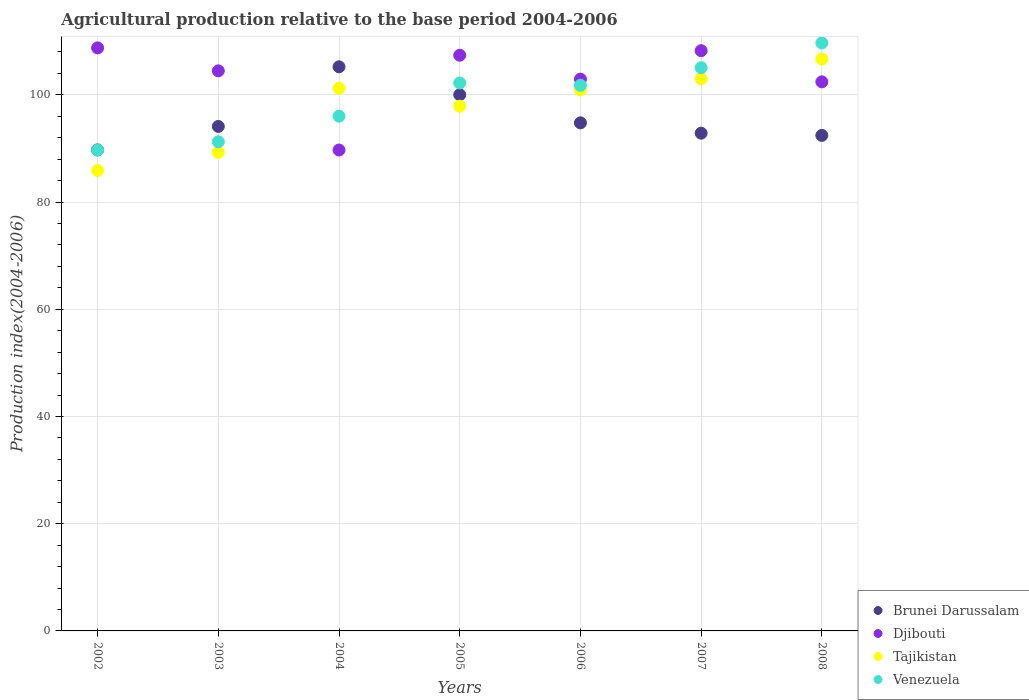What is the agricultural production index in Brunei Darussalam in 2008?
Ensure brevity in your answer.  92.43. Across all years, what is the maximum agricultural production index in Brunei Darussalam?
Your answer should be compact. 105.22. Across all years, what is the minimum agricultural production index in Venezuela?
Make the answer very short. 89.69. In which year was the agricultural production index in Tajikistan minimum?
Your answer should be very brief. 2002. What is the total agricultural production index in Brunei Darussalam in the graph?
Provide a short and direct response. 669.09. What is the difference between the agricultural production index in Venezuela in 2003 and that in 2006?
Give a very brief answer. -10.54. What is the difference between the agricultural production index in Djibouti in 2006 and the agricultural production index in Tajikistan in 2003?
Your response must be concise. 13.66. What is the average agricultural production index in Djibouti per year?
Your answer should be compact. 103.41. In the year 2002, what is the difference between the agricultural production index in Djibouti and agricultural production index in Brunei Darussalam?
Your answer should be very brief. 19.03. In how many years, is the agricultural production index in Tajikistan greater than 44?
Ensure brevity in your answer.  7. What is the ratio of the agricultural production index in Brunei Darussalam in 2003 to that in 2007?
Offer a very short reply. 1.01. Is the agricultural production index in Brunei Darussalam in 2003 less than that in 2005?
Give a very brief answer. Yes. What is the difference between the highest and the second highest agricultural production index in Djibouti?
Your response must be concise. 0.52. What is the difference between the highest and the lowest agricultural production index in Tajikistan?
Keep it short and to the point. 20.8. In how many years, is the agricultural production index in Djibouti greater than the average agricultural production index in Djibouti taken over all years?
Provide a short and direct response. 4. Is the agricultural production index in Djibouti strictly greater than the agricultural production index in Venezuela over the years?
Ensure brevity in your answer.  No. How many years are there in the graph?
Offer a very short reply. 7. Are the values on the major ticks of Y-axis written in scientific E-notation?
Keep it short and to the point. No. Does the graph contain any zero values?
Your answer should be compact. No. Does the graph contain grids?
Offer a terse response. Yes. Where does the legend appear in the graph?
Offer a very short reply. Bottom right. How many legend labels are there?
Give a very brief answer. 4. What is the title of the graph?
Keep it short and to the point. Agricultural production relative to the base period 2004-2006. What is the label or title of the Y-axis?
Make the answer very short. Production index(2004-2006). What is the Production index(2004-2006) in Brunei Darussalam in 2002?
Your answer should be compact. 89.72. What is the Production index(2004-2006) in Djibouti in 2002?
Give a very brief answer. 108.75. What is the Production index(2004-2006) in Tajikistan in 2002?
Give a very brief answer. 85.87. What is the Production index(2004-2006) in Venezuela in 2002?
Your response must be concise. 89.69. What is the Production index(2004-2006) in Brunei Darussalam in 2003?
Ensure brevity in your answer.  94.1. What is the Production index(2004-2006) of Djibouti in 2003?
Offer a very short reply. 104.47. What is the Production index(2004-2006) in Tajikistan in 2003?
Give a very brief answer. 89.26. What is the Production index(2004-2006) of Venezuela in 2003?
Your response must be concise. 91.24. What is the Production index(2004-2006) in Brunei Darussalam in 2004?
Provide a succinct answer. 105.22. What is the Production index(2004-2006) of Djibouti in 2004?
Provide a succinct answer. 89.7. What is the Production index(2004-2006) in Tajikistan in 2004?
Provide a succinct answer. 101.21. What is the Production index(2004-2006) in Venezuela in 2004?
Make the answer very short. 96.01. What is the Production index(2004-2006) of Brunei Darussalam in 2005?
Make the answer very short. 100.01. What is the Production index(2004-2006) in Djibouti in 2005?
Ensure brevity in your answer.  107.38. What is the Production index(2004-2006) of Tajikistan in 2005?
Give a very brief answer. 97.88. What is the Production index(2004-2006) of Venezuela in 2005?
Offer a terse response. 102.21. What is the Production index(2004-2006) in Brunei Darussalam in 2006?
Ensure brevity in your answer.  94.77. What is the Production index(2004-2006) in Djibouti in 2006?
Make the answer very short. 102.92. What is the Production index(2004-2006) in Tajikistan in 2006?
Keep it short and to the point. 100.91. What is the Production index(2004-2006) in Venezuela in 2006?
Ensure brevity in your answer.  101.78. What is the Production index(2004-2006) in Brunei Darussalam in 2007?
Make the answer very short. 92.84. What is the Production index(2004-2006) of Djibouti in 2007?
Give a very brief answer. 108.23. What is the Production index(2004-2006) in Tajikistan in 2007?
Your response must be concise. 102.99. What is the Production index(2004-2006) in Venezuela in 2007?
Make the answer very short. 105.06. What is the Production index(2004-2006) of Brunei Darussalam in 2008?
Provide a short and direct response. 92.43. What is the Production index(2004-2006) of Djibouti in 2008?
Offer a very short reply. 102.42. What is the Production index(2004-2006) of Tajikistan in 2008?
Your answer should be very brief. 106.67. What is the Production index(2004-2006) of Venezuela in 2008?
Your response must be concise. 109.67. Across all years, what is the maximum Production index(2004-2006) of Brunei Darussalam?
Your answer should be very brief. 105.22. Across all years, what is the maximum Production index(2004-2006) of Djibouti?
Offer a very short reply. 108.75. Across all years, what is the maximum Production index(2004-2006) in Tajikistan?
Your response must be concise. 106.67. Across all years, what is the maximum Production index(2004-2006) in Venezuela?
Offer a very short reply. 109.67. Across all years, what is the minimum Production index(2004-2006) of Brunei Darussalam?
Give a very brief answer. 89.72. Across all years, what is the minimum Production index(2004-2006) of Djibouti?
Offer a terse response. 89.7. Across all years, what is the minimum Production index(2004-2006) in Tajikistan?
Offer a terse response. 85.87. Across all years, what is the minimum Production index(2004-2006) of Venezuela?
Provide a succinct answer. 89.69. What is the total Production index(2004-2006) in Brunei Darussalam in the graph?
Your response must be concise. 669.09. What is the total Production index(2004-2006) of Djibouti in the graph?
Your answer should be very brief. 723.87. What is the total Production index(2004-2006) of Tajikistan in the graph?
Your answer should be very brief. 684.79. What is the total Production index(2004-2006) in Venezuela in the graph?
Offer a very short reply. 695.66. What is the difference between the Production index(2004-2006) of Brunei Darussalam in 2002 and that in 2003?
Keep it short and to the point. -4.38. What is the difference between the Production index(2004-2006) in Djibouti in 2002 and that in 2003?
Give a very brief answer. 4.28. What is the difference between the Production index(2004-2006) of Tajikistan in 2002 and that in 2003?
Your answer should be very brief. -3.39. What is the difference between the Production index(2004-2006) in Venezuela in 2002 and that in 2003?
Ensure brevity in your answer.  -1.55. What is the difference between the Production index(2004-2006) in Brunei Darussalam in 2002 and that in 2004?
Your answer should be very brief. -15.5. What is the difference between the Production index(2004-2006) in Djibouti in 2002 and that in 2004?
Offer a very short reply. 19.05. What is the difference between the Production index(2004-2006) in Tajikistan in 2002 and that in 2004?
Provide a succinct answer. -15.34. What is the difference between the Production index(2004-2006) in Venezuela in 2002 and that in 2004?
Provide a short and direct response. -6.32. What is the difference between the Production index(2004-2006) in Brunei Darussalam in 2002 and that in 2005?
Your answer should be compact. -10.29. What is the difference between the Production index(2004-2006) in Djibouti in 2002 and that in 2005?
Offer a terse response. 1.37. What is the difference between the Production index(2004-2006) in Tajikistan in 2002 and that in 2005?
Make the answer very short. -12.01. What is the difference between the Production index(2004-2006) in Venezuela in 2002 and that in 2005?
Offer a terse response. -12.52. What is the difference between the Production index(2004-2006) of Brunei Darussalam in 2002 and that in 2006?
Provide a succinct answer. -5.05. What is the difference between the Production index(2004-2006) of Djibouti in 2002 and that in 2006?
Make the answer very short. 5.83. What is the difference between the Production index(2004-2006) in Tajikistan in 2002 and that in 2006?
Your answer should be very brief. -15.04. What is the difference between the Production index(2004-2006) of Venezuela in 2002 and that in 2006?
Give a very brief answer. -12.09. What is the difference between the Production index(2004-2006) of Brunei Darussalam in 2002 and that in 2007?
Offer a very short reply. -3.12. What is the difference between the Production index(2004-2006) in Djibouti in 2002 and that in 2007?
Your answer should be compact. 0.52. What is the difference between the Production index(2004-2006) in Tajikistan in 2002 and that in 2007?
Your answer should be compact. -17.12. What is the difference between the Production index(2004-2006) of Venezuela in 2002 and that in 2007?
Your answer should be compact. -15.37. What is the difference between the Production index(2004-2006) of Brunei Darussalam in 2002 and that in 2008?
Provide a succinct answer. -2.71. What is the difference between the Production index(2004-2006) of Djibouti in 2002 and that in 2008?
Ensure brevity in your answer.  6.33. What is the difference between the Production index(2004-2006) in Tajikistan in 2002 and that in 2008?
Ensure brevity in your answer.  -20.8. What is the difference between the Production index(2004-2006) of Venezuela in 2002 and that in 2008?
Give a very brief answer. -19.98. What is the difference between the Production index(2004-2006) of Brunei Darussalam in 2003 and that in 2004?
Provide a short and direct response. -11.12. What is the difference between the Production index(2004-2006) of Djibouti in 2003 and that in 2004?
Ensure brevity in your answer.  14.77. What is the difference between the Production index(2004-2006) in Tajikistan in 2003 and that in 2004?
Give a very brief answer. -11.95. What is the difference between the Production index(2004-2006) of Venezuela in 2003 and that in 2004?
Ensure brevity in your answer.  -4.77. What is the difference between the Production index(2004-2006) of Brunei Darussalam in 2003 and that in 2005?
Your answer should be very brief. -5.91. What is the difference between the Production index(2004-2006) in Djibouti in 2003 and that in 2005?
Provide a succinct answer. -2.91. What is the difference between the Production index(2004-2006) of Tajikistan in 2003 and that in 2005?
Your answer should be compact. -8.62. What is the difference between the Production index(2004-2006) of Venezuela in 2003 and that in 2005?
Provide a succinct answer. -10.97. What is the difference between the Production index(2004-2006) in Brunei Darussalam in 2003 and that in 2006?
Give a very brief answer. -0.67. What is the difference between the Production index(2004-2006) in Djibouti in 2003 and that in 2006?
Your answer should be compact. 1.55. What is the difference between the Production index(2004-2006) of Tajikistan in 2003 and that in 2006?
Offer a terse response. -11.65. What is the difference between the Production index(2004-2006) in Venezuela in 2003 and that in 2006?
Offer a very short reply. -10.54. What is the difference between the Production index(2004-2006) in Brunei Darussalam in 2003 and that in 2007?
Your answer should be compact. 1.26. What is the difference between the Production index(2004-2006) in Djibouti in 2003 and that in 2007?
Your answer should be compact. -3.76. What is the difference between the Production index(2004-2006) in Tajikistan in 2003 and that in 2007?
Offer a very short reply. -13.73. What is the difference between the Production index(2004-2006) of Venezuela in 2003 and that in 2007?
Provide a short and direct response. -13.82. What is the difference between the Production index(2004-2006) of Brunei Darussalam in 2003 and that in 2008?
Make the answer very short. 1.67. What is the difference between the Production index(2004-2006) of Djibouti in 2003 and that in 2008?
Your response must be concise. 2.05. What is the difference between the Production index(2004-2006) in Tajikistan in 2003 and that in 2008?
Provide a succinct answer. -17.41. What is the difference between the Production index(2004-2006) in Venezuela in 2003 and that in 2008?
Keep it short and to the point. -18.43. What is the difference between the Production index(2004-2006) of Brunei Darussalam in 2004 and that in 2005?
Give a very brief answer. 5.21. What is the difference between the Production index(2004-2006) in Djibouti in 2004 and that in 2005?
Offer a very short reply. -17.68. What is the difference between the Production index(2004-2006) in Tajikistan in 2004 and that in 2005?
Make the answer very short. 3.33. What is the difference between the Production index(2004-2006) in Venezuela in 2004 and that in 2005?
Provide a short and direct response. -6.2. What is the difference between the Production index(2004-2006) in Brunei Darussalam in 2004 and that in 2006?
Provide a succinct answer. 10.45. What is the difference between the Production index(2004-2006) of Djibouti in 2004 and that in 2006?
Your answer should be compact. -13.22. What is the difference between the Production index(2004-2006) in Venezuela in 2004 and that in 2006?
Your answer should be very brief. -5.77. What is the difference between the Production index(2004-2006) of Brunei Darussalam in 2004 and that in 2007?
Ensure brevity in your answer.  12.38. What is the difference between the Production index(2004-2006) of Djibouti in 2004 and that in 2007?
Keep it short and to the point. -18.53. What is the difference between the Production index(2004-2006) of Tajikistan in 2004 and that in 2007?
Give a very brief answer. -1.78. What is the difference between the Production index(2004-2006) in Venezuela in 2004 and that in 2007?
Your answer should be compact. -9.05. What is the difference between the Production index(2004-2006) of Brunei Darussalam in 2004 and that in 2008?
Offer a terse response. 12.79. What is the difference between the Production index(2004-2006) in Djibouti in 2004 and that in 2008?
Provide a succinct answer. -12.72. What is the difference between the Production index(2004-2006) in Tajikistan in 2004 and that in 2008?
Offer a terse response. -5.46. What is the difference between the Production index(2004-2006) of Venezuela in 2004 and that in 2008?
Offer a very short reply. -13.66. What is the difference between the Production index(2004-2006) of Brunei Darussalam in 2005 and that in 2006?
Offer a very short reply. 5.24. What is the difference between the Production index(2004-2006) of Djibouti in 2005 and that in 2006?
Keep it short and to the point. 4.46. What is the difference between the Production index(2004-2006) in Tajikistan in 2005 and that in 2006?
Your response must be concise. -3.03. What is the difference between the Production index(2004-2006) of Venezuela in 2005 and that in 2006?
Your response must be concise. 0.43. What is the difference between the Production index(2004-2006) of Brunei Darussalam in 2005 and that in 2007?
Provide a short and direct response. 7.17. What is the difference between the Production index(2004-2006) in Djibouti in 2005 and that in 2007?
Give a very brief answer. -0.85. What is the difference between the Production index(2004-2006) in Tajikistan in 2005 and that in 2007?
Keep it short and to the point. -5.11. What is the difference between the Production index(2004-2006) of Venezuela in 2005 and that in 2007?
Keep it short and to the point. -2.85. What is the difference between the Production index(2004-2006) of Brunei Darussalam in 2005 and that in 2008?
Provide a short and direct response. 7.58. What is the difference between the Production index(2004-2006) of Djibouti in 2005 and that in 2008?
Keep it short and to the point. 4.96. What is the difference between the Production index(2004-2006) of Tajikistan in 2005 and that in 2008?
Make the answer very short. -8.79. What is the difference between the Production index(2004-2006) of Venezuela in 2005 and that in 2008?
Offer a terse response. -7.46. What is the difference between the Production index(2004-2006) in Brunei Darussalam in 2006 and that in 2007?
Provide a succinct answer. 1.93. What is the difference between the Production index(2004-2006) of Djibouti in 2006 and that in 2007?
Your answer should be very brief. -5.31. What is the difference between the Production index(2004-2006) of Tajikistan in 2006 and that in 2007?
Make the answer very short. -2.08. What is the difference between the Production index(2004-2006) in Venezuela in 2006 and that in 2007?
Provide a succinct answer. -3.28. What is the difference between the Production index(2004-2006) in Brunei Darussalam in 2006 and that in 2008?
Your response must be concise. 2.34. What is the difference between the Production index(2004-2006) of Djibouti in 2006 and that in 2008?
Your answer should be very brief. 0.5. What is the difference between the Production index(2004-2006) in Tajikistan in 2006 and that in 2008?
Give a very brief answer. -5.76. What is the difference between the Production index(2004-2006) of Venezuela in 2006 and that in 2008?
Provide a short and direct response. -7.89. What is the difference between the Production index(2004-2006) of Brunei Darussalam in 2007 and that in 2008?
Provide a short and direct response. 0.41. What is the difference between the Production index(2004-2006) of Djibouti in 2007 and that in 2008?
Your response must be concise. 5.81. What is the difference between the Production index(2004-2006) of Tajikistan in 2007 and that in 2008?
Your answer should be compact. -3.68. What is the difference between the Production index(2004-2006) of Venezuela in 2007 and that in 2008?
Give a very brief answer. -4.61. What is the difference between the Production index(2004-2006) in Brunei Darussalam in 2002 and the Production index(2004-2006) in Djibouti in 2003?
Keep it short and to the point. -14.75. What is the difference between the Production index(2004-2006) of Brunei Darussalam in 2002 and the Production index(2004-2006) of Tajikistan in 2003?
Your answer should be compact. 0.46. What is the difference between the Production index(2004-2006) in Brunei Darussalam in 2002 and the Production index(2004-2006) in Venezuela in 2003?
Keep it short and to the point. -1.52. What is the difference between the Production index(2004-2006) in Djibouti in 2002 and the Production index(2004-2006) in Tajikistan in 2003?
Provide a succinct answer. 19.49. What is the difference between the Production index(2004-2006) in Djibouti in 2002 and the Production index(2004-2006) in Venezuela in 2003?
Ensure brevity in your answer.  17.51. What is the difference between the Production index(2004-2006) in Tajikistan in 2002 and the Production index(2004-2006) in Venezuela in 2003?
Offer a terse response. -5.37. What is the difference between the Production index(2004-2006) of Brunei Darussalam in 2002 and the Production index(2004-2006) of Tajikistan in 2004?
Your answer should be compact. -11.49. What is the difference between the Production index(2004-2006) in Brunei Darussalam in 2002 and the Production index(2004-2006) in Venezuela in 2004?
Give a very brief answer. -6.29. What is the difference between the Production index(2004-2006) of Djibouti in 2002 and the Production index(2004-2006) of Tajikistan in 2004?
Offer a terse response. 7.54. What is the difference between the Production index(2004-2006) in Djibouti in 2002 and the Production index(2004-2006) in Venezuela in 2004?
Your response must be concise. 12.74. What is the difference between the Production index(2004-2006) in Tajikistan in 2002 and the Production index(2004-2006) in Venezuela in 2004?
Offer a very short reply. -10.14. What is the difference between the Production index(2004-2006) of Brunei Darussalam in 2002 and the Production index(2004-2006) of Djibouti in 2005?
Make the answer very short. -17.66. What is the difference between the Production index(2004-2006) in Brunei Darussalam in 2002 and the Production index(2004-2006) in Tajikistan in 2005?
Offer a terse response. -8.16. What is the difference between the Production index(2004-2006) in Brunei Darussalam in 2002 and the Production index(2004-2006) in Venezuela in 2005?
Make the answer very short. -12.49. What is the difference between the Production index(2004-2006) in Djibouti in 2002 and the Production index(2004-2006) in Tajikistan in 2005?
Ensure brevity in your answer.  10.87. What is the difference between the Production index(2004-2006) in Djibouti in 2002 and the Production index(2004-2006) in Venezuela in 2005?
Provide a short and direct response. 6.54. What is the difference between the Production index(2004-2006) in Tajikistan in 2002 and the Production index(2004-2006) in Venezuela in 2005?
Give a very brief answer. -16.34. What is the difference between the Production index(2004-2006) of Brunei Darussalam in 2002 and the Production index(2004-2006) of Djibouti in 2006?
Ensure brevity in your answer.  -13.2. What is the difference between the Production index(2004-2006) in Brunei Darussalam in 2002 and the Production index(2004-2006) in Tajikistan in 2006?
Provide a succinct answer. -11.19. What is the difference between the Production index(2004-2006) in Brunei Darussalam in 2002 and the Production index(2004-2006) in Venezuela in 2006?
Your response must be concise. -12.06. What is the difference between the Production index(2004-2006) in Djibouti in 2002 and the Production index(2004-2006) in Tajikistan in 2006?
Provide a succinct answer. 7.84. What is the difference between the Production index(2004-2006) in Djibouti in 2002 and the Production index(2004-2006) in Venezuela in 2006?
Your response must be concise. 6.97. What is the difference between the Production index(2004-2006) of Tajikistan in 2002 and the Production index(2004-2006) of Venezuela in 2006?
Provide a succinct answer. -15.91. What is the difference between the Production index(2004-2006) of Brunei Darussalam in 2002 and the Production index(2004-2006) of Djibouti in 2007?
Keep it short and to the point. -18.51. What is the difference between the Production index(2004-2006) in Brunei Darussalam in 2002 and the Production index(2004-2006) in Tajikistan in 2007?
Provide a succinct answer. -13.27. What is the difference between the Production index(2004-2006) of Brunei Darussalam in 2002 and the Production index(2004-2006) of Venezuela in 2007?
Offer a very short reply. -15.34. What is the difference between the Production index(2004-2006) of Djibouti in 2002 and the Production index(2004-2006) of Tajikistan in 2007?
Ensure brevity in your answer.  5.76. What is the difference between the Production index(2004-2006) of Djibouti in 2002 and the Production index(2004-2006) of Venezuela in 2007?
Keep it short and to the point. 3.69. What is the difference between the Production index(2004-2006) of Tajikistan in 2002 and the Production index(2004-2006) of Venezuela in 2007?
Your response must be concise. -19.19. What is the difference between the Production index(2004-2006) of Brunei Darussalam in 2002 and the Production index(2004-2006) of Djibouti in 2008?
Offer a terse response. -12.7. What is the difference between the Production index(2004-2006) in Brunei Darussalam in 2002 and the Production index(2004-2006) in Tajikistan in 2008?
Give a very brief answer. -16.95. What is the difference between the Production index(2004-2006) in Brunei Darussalam in 2002 and the Production index(2004-2006) in Venezuela in 2008?
Offer a very short reply. -19.95. What is the difference between the Production index(2004-2006) of Djibouti in 2002 and the Production index(2004-2006) of Tajikistan in 2008?
Your answer should be compact. 2.08. What is the difference between the Production index(2004-2006) of Djibouti in 2002 and the Production index(2004-2006) of Venezuela in 2008?
Offer a terse response. -0.92. What is the difference between the Production index(2004-2006) of Tajikistan in 2002 and the Production index(2004-2006) of Venezuela in 2008?
Give a very brief answer. -23.8. What is the difference between the Production index(2004-2006) of Brunei Darussalam in 2003 and the Production index(2004-2006) of Djibouti in 2004?
Keep it short and to the point. 4.4. What is the difference between the Production index(2004-2006) in Brunei Darussalam in 2003 and the Production index(2004-2006) in Tajikistan in 2004?
Your answer should be compact. -7.11. What is the difference between the Production index(2004-2006) of Brunei Darussalam in 2003 and the Production index(2004-2006) of Venezuela in 2004?
Your answer should be very brief. -1.91. What is the difference between the Production index(2004-2006) in Djibouti in 2003 and the Production index(2004-2006) in Tajikistan in 2004?
Give a very brief answer. 3.26. What is the difference between the Production index(2004-2006) in Djibouti in 2003 and the Production index(2004-2006) in Venezuela in 2004?
Ensure brevity in your answer.  8.46. What is the difference between the Production index(2004-2006) in Tajikistan in 2003 and the Production index(2004-2006) in Venezuela in 2004?
Ensure brevity in your answer.  -6.75. What is the difference between the Production index(2004-2006) in Brunei Darussalam in 2003 and the Production index(2004-2006) in Djibouti in 2005?
Make the answer very short. -13.28. What is the difference between the Production index(2004-2006) in Brunei Darussalam in 2003 and the Production index(2004-2006) in Tajikistan in 2005?
Provide a short and direct response. -3.78. What is the difference between the Production index(2004-2006) of Brunei Darussalam in 2003 and the Production index(2004-2006) of Venezuela in 2005?
Ensure brevity in your answer.  -8.11. What is the difference between the Production index(2004-2006) of Djibouti in 2003 and the Production index(2004-2006) of Tajikistan in 2005?
Give a very brief answer. 6.59. What is the difference between the Production index(2004-2006) in Djibouti in 2003 and the Production index(2004-2006) in Venezuela in 2005?
Give a very brief answer. 2.26. What is the difference between the Production index(2004-2006) of Tajikistan in 2003 and the Production index(2004-2006) of Venezuela in 2005?
Your response must be concise. -12.95. What is the difference between the Production index(2004-2006) in Brunei Darussalam in 2003 and the Production index(2004-2006) in Djibouti in 2006?
Offer a terse response. -8.82. What is the difference between the Production index(2004-2006) in Brunei Darussalam in 2003 and the Production index(2004-2006) in Tajikistan in 2006?
Ensure brevity in your answer.  -6.81. What is the difference between the Production index(2004-2006) of Brunei Darussalam in 2003 and the Production index(2004-2006) of Venezuela in 2006?
Your response must be concise. -7.68. What is the difference between the Production index(2004-2006) in Djibouti in 2003 and the Production index(2004-2006) in Tajikistan in 2006?
Keep it short and to the point. 3.56. What is the difference between the Production index(2004-2006) of Djibouti in 2003 and the Production index(2004-2006) of Venezuela in 2006?
Offer a terse response. 2.69. What is the difference between the Production index(2004-2006) of Tajikistan in 2003 and the Production index(2004-2006) of Venezuela in 2006?
Your response must be concise. -12.52. What is the difference between the Production index(2004-2006) of Brunei Darussalam in 2003 and the Production index(2004-2006) of Djibouti in 2007?
Ensure brevity in your answer.  -14.13. What is the difference between the Production index(2004-2006) in Brunei Darussalam in 2003 and the Production index(2004-2006) in Tajikistan in 2007?
Give a very brief answer. -8.89. What is the difference between the Production index(2004-2006) of Brunei Darussalam in 2003 and the Production index(2004-2006) of Venezuela in 2007?
Offer a terse response. -10.96. What is the difference between the Production index(2004-2006) in Djibouti in 2003 and the Production index(2004-2006) in Tajikistan in 2007?
Ensure brevity in your answer.  1.48. What is the difference between the Production index(2004-2006) in Djibouti in 2003 and the Production index(2004-2006) in Venezuela in 2007?
Your answer should be compact. -0.59. What is the difference between the Production index(2004-2006) in Tajikistan in 2003 and the Production index(2004-2006) in Venezuela in 2007?
Your answer should be compact. -15.8. What is the difference between the Production index(2004-2006) in Brunei Darussalam in 2003 and the Production index(2004-2006) in Djibouti in 2008?
Offer a terse response. -8.32. What is the difference between the Production index(2004-2006) of Brunei Darussalam in 2003 and the Production index(2004-2006) of Tajikistan in 2008?
Your answer should be very brief. -12.57. What is the difference between the Production index(2004-2006) of Brunei Darussalam in 2003 and the Production index(2004-2006) of Venezuela in 2008?
Provide a short and direct response. -15.57. What is the difference between the Production index(2004-2006) in Djibouti in 2003 and the Production index(2004-2006) in Tajikistan in 2008?
Ensure brevity in your answer.  -2.2. What is the difference between the Production index(2004-2006) in Tajikistan in 2003 and the Production index(2004-2006) in Venezuela in 2008?
Give a very brief answer. -20.41. What is the difference between the Production index(2004-2006) of Brunei Darussalam in 2004 and the Production index(2004-2006) of Djibouti in 2005?
Provide a short and direct response. -2.16. What is the difference between the Production index(2004-2006) in Brunei Darussalam in 2004 and the Production index(2004-2006) in Tajikistan in 2005?
Offer a terse response. 7.34. What is the difference between the Production index(2004-2006) in Brunei Darussalam in 2004 and the Production index(2004-2006) in Venezuela in 2005?
Your answer should be compact. 3.01. What is the difference between the Production index(2004-2006) of Djibouti in 2004 and the Production index(2004-2006) of Tajikistan in 2005?
Your answer should be compact. -8.18. What is the difference between the Production index(2004-2006) of Djibouti in 2004 and the Production index(2004-2006) of Venezuela in 2005?
Your answer should be compact. -12.51. What is the difference between the Production index(2004-2006) in Brunei Darussalam in 2004 and the Production index(2004-2006) in Djibouti in 2006?
Your response must be concise. 2.3. What is the difference between the Production index(2004-2006) in Brunei Darussalam in 2004 and the Production index(2004-2006) in Tajikistan in 2006?
Keep it short and to the point. 4.31. What is the difference between the Production index(2004-2006) in Brunei Darussalam in 2004 and the Production index(2004-2006) in Venezuela in 2006?
Give a very brief answer. 3.44. What is the difference between the Production index(2004-2006) of Djibouti in 2004 and the Production index(2004-2006) of Tajikistan in 2006?
Offer a very short reply. -11.21. What is the difference between the Production index(2004-2006) of Djibouti in 2004 and the Production index(2004-2006) of Venezuela in 2006?
Ensure brevity in your answer.  -12.08. What is the difference between the Production index(2004-2006) in Tajikistan in 2004 and the Production index(2004-2006) in Venezuela in 2006?
Make the answer very short. -0.57. What is the difference between the Production index(2004-2006) of Brunei Darussalam in 2004 and the Production index(2004-2006) of Djibouti in 2007?
Your answer should be very brief. -3.01. What is the difference between the Production index(2004-2006) in Brunei Darussalam in 2004 and the Production index(2004-2006) in Tajikistan in 2007?
Offer a very short reply. 2.23. What is the difference between the Production index(2004-2006) of Brunei Darussalam in 2004 and the Production index(2004-2006) of Venezuela in 2007?
Your answer should be compact. 0.16. What is the difference between the Production index(2004-2006) of Djibouti in 2004 and the Production index(2004-2006) of Tajikistan in 2007?
Give a very brief answer. -13.29. What is the difference between the Production index(2004-2006) in Djibouti in 2004 and the Production index(2004-2006) in Venezuela in 2007?
Your answer should be very brief. -15.36. What is the difference between the Production index(2004-2006) of Tajikistan in 2004 and the Production index(2004-2006) of Venezuela in 2007?
Provide a short and direct response. -3.85. What is the difference between the Production index(2004-2006) of Brunei Darussalam in 2004 and the Production index(2004-2006) of Djibouti in 2008?
Make the answer very short. 2.8. What is the difference between the Production index(2004-2006) in Brunei Darussalam in 2004 and the Production index(2004-2006) in Tajikistan in 2008?
Make the answer very short. -1.45. What is the difference between the Production index(2004-2006) in Brunei Darussalam in 2004 and the Production index(2004-2006) in Venezuela in 2008?
Keep it short and to the point. -4.45. What is the difference between the Production index(2004-2006) of Djibouti in 2004 and the Production index(2004-2006) of Tajikistan in 2008?
Your answer should be compact. -16.97. What is the difference between the Production index(2004-2006) of Djibouti in 2004 and the Production index(2004-2006) of Venezuela in 2008?
Provide a succinct answer. -19.97. What is the difference between the Production index(2004-2006) in Tajikistan in 2004 and the Production index(2004-2006) in Venezuela in 2008?
Offer a very short reply. -8.46. What is the difference between the Production index(2004-2006) of Brunei Darussalam in 2005 and the Production index(2004-2006) of Djibouti in 2006?
Your answer should be compact. -2.91. What is the difference between the Production index(2004-2006) of Brunei Darussalam in 2005 and the Production index(2004-2006) of Tajikistan in 2006?
Ensure brevity in your answer.  -0.9. What is the difference between the Production index(2004-2006) of Brunei Darussalam in 2005 and the Production index(2004-2006) of Venezuela in 2006?
Your answer should be compact. -1.77. What is the difference between the Production index(2004-2006) in Djibouti in 2005 and the Production index(2004-2006) in Tajikistan in 2006?
Offer a terse response. 6.47. What is the difference between the Production index(2004-2006) of Tajikistan in 2005 and the Production index(2004-2006) of Venezuela in 2006?
Your answer should be very brief. -3.9. What is the difference between the Production index(2004-2006) in Brunei Darussalam in 2005 and the Production index(2004-2006) in Djibouti in 2007?
Your answer should be very brief. -8.22. What is the difference between the Production index(2004-2006) in Brunei Darussalam in 2005 and the Production index(2004-2006) in Tajikistan in 2007?
Make the answer very short. -2.98. What is the difference between the Production index(2004-2006) of Brunei Darussalam in 2005 and the Production index(2004-2006) of Venezuela in 2007?
Your response must be concise. -5.05. What is the difference between the Production index(2004-2006) in Djibouti in 2005 and the Production index(2004-2006) in Tajikistan in 2007?
Give a very brief answer. 4.39. What is the difference between the Production index(2004-2006) of Djibouti in 2005 and the Production index(2004-2006) of Venezuela in 2007?
Provide a short and direct response. 2.32. What is the difference between the Production index(2004-2006) of Tajikistan in 2005 and the Production index(2004-2006) of Venezuela in 2007?
Offer a very short reply. -7.18. What is the difference between the Production index(2004-2006) of Brunei Darussalam in 2005 and the Production index(2004-2006) of Djibouti in 2008?
Offer a very short reply. -2.41. What is the difference between the Production index(2004-2006) in Brunei Darussalam in 2005 and the Production index(2004-2006) in Tajikistan in 2008?
Provide a succinct answer. -6.66. What is the difference between the Production index(2004-2006) of Brunei Darussalam in 2005 and the Production index(2004-2006) of Venezuela in 2008?
Your answer should be very brief. -9.66. What is the difference between the Production index(2004-2006) in Djibouti in 2005 and the Production index(2004-2006) in Tajikistan in 2008?
Give a very brief answer. 0.71. What is the difference between the Production index(2004-2006) in Djibouti in 2005 and the Production index(2004-2006) in Venezuela in 2008?
Provide a succinct answer. -2.29. What is the difference between the Production index(2004-2006) in Tajikistan in 2005 and the Production index(2004-2006) in Venezuela in 2008?
Offer a very short reply. -11.79. What is the difference between the Production index(2004-2006) in Brunei Darussalam in 2006 and the Production index(2004-2006) in Djibouti in 2007?
Make the answer very short. -13.46. What is the difference between the Production index(2004-2006) in Brunei Darussalam in 2006 and the Production index(2004-2006) in Tajikistan in 2007?
Make the answer very short. -8.22. What is the difference between the Production index(2004-2006) of Brunei Darussalam in 2006 and the Production index(2004-2006) of Venezuela in 2007?
Offer a very short reply. -10.29. What is the difference between the Production index(2004-2006) of Djibouti in 2006 and the Production index(2004-2006) of Tajikistan in 2007?
Provide a succinct answer. -0.07. What is the difference between the Production index(2004-2006) in Djibouti in 2006 and the Production index(2004-2006) in Venezuela in 2007?
Your answer should be compact. -2.14. What is the difference between the Production index(2004-2006) in Tajikistan in 2006 and the Production index(2004-2006) in Venezuela in 2007?
Offer a terse response. -4.15. What is the difference between the Production index(2004-2006) in Brunei Darussalam in 2006 and the Production index(2004-2006) in Djibouti in 2008?
Offer a terse response. -7.65. What is the difference between the Production index(2004-2006) of Brunei Darussalam in 2006 and the Production index(2004-2006) of Venezuela in 2008?
Your answer should be very brief. -14.9. What is the difference between the Production index(2004-2006) of Djibouti in 2006 and the Production index(2004-2006) of Tajikistan in 2008?
Provide a succinct answer. -3.75. What is the difference between the Production index(2004-2006) of Djibouti in 2006 and the Production index(2004-2006) of Venezuela in 2008?
Your answer should be compact. -6.75. What is the difference between the Production index(2004-2006) in Tajikistan in 2006 and the Production index(2004-2006) in Venezuela in 2008?
Your response must be concise. -8.76. What is the difference between the Production index(2004-2006) of Brunei Darussalam in 2007 and the Production index(2004-2006) of Djibouti in 2008?
Offer a terse response. -9.58. What is the difference between the Production index(2004-2006) of Brunei Darussalam in 2007 and the Production index(2004-2006) of Tajikistan in 2008?
Offer a very short reply. -13.83. What is the difference between the Production index(2004-2006) of Brunei Darussalam in 2007 and the Production index(2004-2006) of Venezuela in 2008?
Offer a terse response. -16.83. What is the difference between the Production index(2004-2006) in Djibouti in 2007 and the Production index(2004-2006) in Tajikistan in 2008?
Offer a terse response. 1.56. What is the difference between the Production index(2004-2006) in Djibouti in 2007 and the Production index(2004-2006) in Venezuela in 2008?
Provide a short and direct response. -1.44. What is the difference between the Production index(2004-2006) of Tajikistan in 2007 and the Production index(2004-2006) of Venezuela in 2008?
Your answer should be very brief. -6.68. What is the average Production index(2004-2006) in Brunei Darussalam per year?
Offer a very short reply. 95.58. What is the average Production index(2004-2006) of Djibouti per year?
Your response must be concise. 103.41. What is the average Production index(2004-2006) of Tajikistan per year?
Give a very brief answer. 97.83. What is the average Production index(2004-2006) of Venezuela per year?
Your answer should be compact. 99.38. In the year 2002, what is the difference between the Production index(2004-2006) of Brunei Darussalam and Production index(2004-2006) of Djibouti?
Provide a succinct answer. -19.03. In the year 2002, what is the difference between the Production index(2004-2006) in Brunei Darussalam and Production index(2004-2006) in Tajikistan?
Make the answer very short. 3.85. In the year 2002, what is the difference between the Production index(2004-2006) in Djibouti and Production index(2004-2006) in Tajikistan?
Make the answer very short. 22.88. In the year 2002, what is the difference between the Production index(2004-2006) of Djibouti and Production index(2004-2006) of Venezuela?
Your response must be concise. 19.06. In the year 2002, what is the difference between the Production index(2004-2006) of Tajikistan and Production index(2004-2006) of Venezuela?
Give a very brief answer. -3.82. In the year 2003, what is the difference between the Production index(2004-2006) in Brunei Darussalam and Production index(2004-2006) in Djibouti?
Provide a short and direct response. -10.37. In the year 2003, what is the difference between the Production index(2004-2006) in Brunei Darussalam and Production index(2004-2006) in Tajikistan?
Offer a very short reply. 4.84. In the year 2003, what is the difference between the Production index(2004-2006) of Brunei Darussalam and Production index(2004-2006) of Venezuela?
Offer a terse response. 2.86. In the year 2003, what is the difference between the Production index(2004-2006) of Djibouti and Production index(2004-2006) of Tajikistan?
Offer a very short reply. 15.21. In the year 2003, what is the difference between the Production index(2004-2006) of Djibouti and Production index(2004-2006) of Venezuela?
Your answer should be compact. 13.23. In the year 2003, what is the difference between the Production index(2004-2006) of Tajikistan and Production index(2004-2006) of Venezuela?
Ensure brevity in your answer.  -1.98. In the year 2004, what is the difference between the Production index(2004-2006) in Brunei Darussalam and Production index(2004-2006) in Djibouti?
Offer a very short reply. 15.52. In the year 2004, what is the difference between the Production index(2004-2006) of Brunei Darussalam and Production index(2004-2006) of Tajikistan?
Keep it short and to the point. 4.01. In the year 2004, what is the difference between the Production index(2004-2006) of Brunei Darussalam and Production index(2004-2006) of Venezuela?
Your response must be concise. 9.21. In the year 2004, what is the difference between the Production index(2004-2006) of Djibouti and Production index(2004-2006) of Tajikistan?
Provide a short and direct response. -11.51. In the year 2004, what is the difference between the Production index(2004-2006) in Djibouti and Production index(2004-2006) in Venezuela?
Your response must be concise. -6.31. In the year 2005, what is the difference between the Production index(2004-2006) of Brunei Darussalam and Production index(2004-2006) of Djibouti?
Give a very brief answer. -7.37. In the year 2005, what is the difference between the Production index(2004-2006) of Brunei Darussalam and Production index(2004-2006) of Tajikistan?
Keep it short and to the point. 2.13. In the year 2005, what is the difference between the Production index(2004-2006) of Brunei Darussalam and Production index(2004-2006) of Venezuela?
Provide a succinct answer. -2.2. In the year 2005, what is the difference between the Production index(2004-2006) of Djibouti and Production index(2004-2006) of Tajikistan?
Provide a succinct answer. 9.5. In the year 2005, what is the difference between the Production index(2004-2006) in Djibouti and Production index(2004-2006) in Venezuela?
Your answer should be very brief. 5.17. In the year 2005, what is the difference between the Production index(2004-2006) of Tajikistan and Production index(2004-2006) of Venezuela?
Your answer should be compact. -4.33. In the year 2006, what is the difference between the Production index(2004-2006) of Brunei Darussalam and Production index(2004-2006) of Djibouti?
Provide a short and direct response. -8.15. In the year 2006, what is the difference between the Production index(2004-2006) of Brunei Darussalam and Production index(2004-2006) of Tajikistan?
Ensure brevity in your answer.  -6.14. In the year 2006, what is the difference between the Production index(2004-2006) in Brunei Darussalam and Production index(2004-2006) in Venezuela?
Provide a succinct answer. -7.01. In the year 2006, what is the difference between the Production index(2004-2006) in Djibouti and Production index(2004-2006) in Tajikistan?
Give a very brief answer. 2.01. In the year 2006, what is the difference between the Production index(2004-2006) in Djibouti and Production index(2004-2006) in Venezuela?
Keep it short and to the point. 1.14. In the year 2006, what is the difference between the Production index(2004-2006) of Tajikistan and Production index(2004-2006) of Venezuela?
Your response must be concise. -0.87. In the year 2007, what is the difference between the Production index(2004-2006) of Brunei Darussalam and Production index(2004-2006) of Djibouti?
Offer a very short reply. -15.39. In the year 2007, what is the difference between the Production index(2004-2006) of Brunei Darussalam and Production index(2004-2006) of Tajikistan?
Make the answer very short. -10.15. In the year 2007, what is the difference between the Production index(2004-2006) of Brunei Darussalam and Production index(2004-2006) of Venezuela?
Offer a terse response. -12.22. In the year 2007, what is the difference between the Production index(2004-2006) in Djibouti and Production index(2004-2006) in Tajikistan?
Your answer should be compact. 5.24. In the year 2007, what is the difference between the Production index(2004-2006) in Djibouti and Production index(2004-2006) in Venezuela?
Offer a very short reply. 3.17. In the year 2007, what is the difference between the Production index(2004-2006) in Tajikistan and Production index(2004-2006) in Venezuela?
Your answer should be compact. -2.07. In the year 2008, what is the difference between the Production index(2004-2006) in Brunei Darussalam and Production index(2004-2006) in Djibouti?
Make the answer very short. -9.99. In the year 2008, what is the difference between the Production index(2004-2006) of Brunei Darussalam and Production index(2004-2006) of Tajikistan?
Keep it short and to the point. -14.24. In the year 2008, what is the difference between the Production index(2004-2006) of Brunei Darussalam and Production index(2004-2006) of Venezuela?
Offer a terse response. -17.24. In the year 2008, what is the difference between the Production index(2004-2006) of Djibouti and Production index(2004-2006) of Tajikistan?
Your answer should be very brief. -4.25. In the year 2008, what is the difference between the Production index(2004-2006) of Djibouti and Production index(2004-2006) of Venezuela?
Make the answer very short. -7.25. In the year 2008, what is the difference between the Production index(2004-2006) of Tajikistan and Production index(2004-2006) of Venezuela?
Give a very brief answer. -3. What is the ratio of the Production index(2004-2006) of Brunei Darussalam in 2002 to that in 2003?
Your answer should be compact. 0.95. What is the ratio of the Production index(2004-2006) in Djibouti in 2002 to that in 2003?
Provide a succinct answer. 1.04. What is the ratio of the Production index(2004-2006) in Venezuela in 2002 to that in 2003?
Give a very brief answer. 0.98. What is the ratio of the Production index(2004-2006) in Brunei Darussalam in 2002 to that in 2004?
Keep it short and to the point. 0.85. What is the ratio of the Production index(2004-2006) of Djibouti in 2002 to that in 2004?
Ensure brevity in your answer.  1.21. What is the ratio of the Production index(2004-2006) in Tajikistan in 2002 to that in 2004?
Keep it short and to the point. 0.85. What is the ratio of the Production index(2004-2006) of Venezuela in 2002 to that in 2004?
Ensure brevity in your answer.  0.93. What is the ratio of the Production index(2004-2006) of Brunei Darussalam in 2002 to that in 2005?
Provide a short and direct response. 0.9. What is the ratio of the Production index(2004-2006) of Djibouti in 2002 to that in 2005?
Your answer should be very brief. 1.01. What is the ratio of the Production index(2004-2006) of Tajikistan in 2002 to that in 2005?
Offer a terse response. 0.88. What is the ratio of the Production index(2004-2006) of Venezuela in 2002 to that in 2005?
Offer a very short reply. 0.88. What is the ratio of the Production index(2004-2006) in Brunei Darussalam in 2002 to that in 2006?
Your answer should be compact. 0.95. What is the ratio of the Production index(2004-2006) of Djibouti in 2002 to that in 2006?
Provide a short and direct response. 1.06. What is the ratio of the Production index(2004-2006) of Tajikistan in 2002 to that in 2006?
Provide a succinct answer. 0.85. What is the ratio of the Production index(2004-2006) of Venezuela in 2002 to that in 2006?
Keep it short and to the point. 0.88. What is the ratio of the Production index(2004-2006) of Brunei Darussalam in 2002 to that in 2007?
Keep it short and to the point. 0.97. What is the ratio of the Production index(2004-2006) of Tajikistan in 2002 to that in 2007?
Provide a succinct answer. 0.83. What is the ratio of the Production index(2004-2006) in Venezuela in 2002 to that in 2007?
Your response must be concise. 0.85. What is the ratio of the Production index(2004-2006) of Brunei Darussalam in 2002 to that in 2008?
Your response must be concise. 0.97. What is the ratio of the Production index(2004-2006) in Djibouti in 2002 to that in 2008?
Offer a terse response. 1.06. What is the ratio of the Production index(2004-2006) in Tajikistan in 2002 to that in 2008?
Give a very brief answer. 0.81. What is the ratio of the Production index(2004-2006) of Venezuela in 2002 to that in 2008?
Your response must be concise. 0.82. What is the ratio of the Production index(2004-2006) of Brunei Darussalam in 2003 to that in 2004?
Provide a short and direct response. 0.89. What is the ratio of the Production index(2004-2006) in Djibouti in 2003 to that in 2004?
Provide a short and direct response. 1.16. What is the ratio of the Production index(2004-2006) in Tajikistan in 2003 to that in 2004?
Offer a terse response. 0.88. What is the ratio of the Production index(2004-2006) in Venezuela in 2003 to that in 2004?
Your answer should be compact. 0.95. What is the ratio of the Production index(2004-2006) of Brunei Darussalam in 2003 to that in 2005?
Give a very brief answer. 0.94. What is the ratio of the Production index(2004-2006) of Djibouti in 2003 to that in 2005?
Provide a succinct answer. 0.97. What is the ratio of the Production index(2004-2006) in Tajikistan in 2003 to that in 2005?
Your answer should be compact. 0.91. What is the ratio of the Production index(2004-2006) in Venezuela in 2003 to that in 2005?
Ensure brevity in your answer.  0.89. What is the ratio of the Production index(2004-2006) of Djibouti in 2003 to that in 2006?
Your answer should be very brief. 1.02. What is the ratio of the Production index(2004-2006) in Tajikistan in 2003 to that in 2006?
Offer a terse response. 0.88. What is the ratio of the Production index(2004-2006) in Venezuela in 2003 to that in 2006?
Offer a very short reply. 0.9. What is the ratio of the Production index(2004-2006) in Brunei Darussalam in 2003 to that in 2007?
Your answer should be compact. 1.01. What is the ratio of the Production index(2004-2006) in Djibouti in 2003 to that in 2007?
Make the answer very short. 0.97. What is the ratio of the Production index(2004-2006) in Tajikistan in 2003 to that in 2007?
Offer a terse response. 0.87. What is the ratio of the Production index(2004-2006) of Venezuela in 2003 to that in 2007?
Keep it short and to the point. 0.87. What is the ratio of the Production index(2004-2006) in Brunei Darussalam in 2003 to that in 2008?
Offer a very short reply. 1.02. What is the ratio of the Production index(2004-2006) of Tajikistan in 2003 to that in 2008?
Your response must be concise. 0.84. What is the ratio of the Production index(2004-2006) in Venezuela in 2003 to that in 2008?
Your response must be concise. 0.83. What is the ratio of the Production index(2004-2006) in Brunei Darussalam in 2004 to that in 2005?
Your answer should be very brief. 1.05. What is the ratio of the Production index(2004-2006) of Djibouti in 2004 to that in 2005?
Provide a succinct answer. 0.84. What is the ratio of the Production index(2004-2006) of Tajikistan in 2004 to that in 2005?
Your answer should be very brief. 1.03. What is the ratio of the Production index(2004-2006) of Venezuela in 2004 to that in 2005?
Ensure brevity in your answer.  0.94. What is the ratio of the Production index(2004-2006) of Brunei Darussalam in 2004 to that in 2006?
Make the answer very short. 1.11. What is the ratio of the Production index(2004-2006) of Djibouti in 2004 to that in 2006?
Provide a short and direct response. 0.87. What is the ratio of the Production index(2004-2006) of Venezuela in 2004 to that in 2006?
Your answer should be very brief. 0.94. What is the ratio of the Production index(2004-2006) of Brunei Darussalam in 2004 to that in 2007?
Provide a succinct answer. 1.13. What is the ratio of the Production index(2004-2006) in Djibouti in 2004 to that in 2007?
Give a very brief answer. 0.83. What is the ratio of the Production index(2004-2006) of Tajikistan in 2004 to that in 2007?
Give a very brief answer. 0.98. What is the ratio of the Production index(2004-2006) of Venezuela in 2004 to that in 2007?
Your answer should be compact. 0.91. What is the ratio of the Production index(2004-2006) of Brunei Darussalam in 2004 to that in 2008?
Offer a terse response. 1.14. What is the ratio of the Production index(2004-2006) in Djibouti in 2004 to that in 2008?
Make the answer very short. 0.88. What is the ratio of the Production index(2004-2006) of Tajikistan in 2004 to that in 2008?
Give a very brief answer. 0.95. What is the ratio of the Production index(2004-2006) in Venezuela in 2004 to that in 2008?
Make the answer very short. 0.88. What is the ratio of the Production index(2004-2006) in Brunei Darussalam in 2005 to that in 2006?
Your answer should be very brief. 1.06. What is the ratio of the Production index(2004-2006) in Djibouti in 2005 to that in 2006?
Your answer should be compact. 1.04. What is the ratio of the Production index(2004-2006) of Tajikistan in 2005 to that in 2006?
Ensure brevity in your answer.  0.97. What is the ratio of the Production index(2004-2006) of Venezuela in 2005 to that in 2006?
Keep it short and to the point. 1. What is the ratio of the Production index(2004-2006) in Brunei Darussalam in 2005 to that in 2007?
Offer a very short reply. 1.08. What is the ratio of the Production index(2004-2006) in Tajikistan in 2005 to that in 2007?
Your response must be concise. 0.95. What is the ratio of the Production index(2004-2006) of Venezuela in 2005 to that in 2007?
Your answer should be compact. 0.97. What is the ratio of the Production index(2004-2006) in Brunei Darussalam in 2005 to that in 2008?
Your response must be concise. 1.08. What is the ratio of the Production index(2004-2006) of Djibouti in 2005 to that in 2008?
Keep it short and to the point. 1.05. What is the ratio of the Production index(2004-2006) in Tajikistan in 2005 to that in 2008?
Your response must be concise. 0.92. What is the ratio of the Production index(2004-2006) of Venezuela in 2005 to that in 2008?
Your response must be concise. 0.93. What is the ratio of the Production index(2004-2006) of Brunei Darussalam in 2006 to that in 2007?
Ensure brevity in your answer.  1.02. What is the ratio of the Production index(2004-2006) of Djibouti in 2006 to that in 2007?
Your response must be concise. 0.95. What is the ratio of the Production index(2004-2006) in Tajikistan in 2006 to that in 2007?
Provide a short and direct response. 0.98. What is the ratio of the Production index(2004-2006) in Venezuela in 2006 to that in 2007?
Your answer should be very brief. 0.97. What is the ratio of the Production index(2004-2006) in Brunei Darussalam in 2006 to that in 2008?
Your response must be concise. 1.03. What is the ratio of the Production index(2004-2006) of Tajikistan in 2006 to that in 2008?
Offer a terse response. 0.95. What is the ratio of the Production index(2004-2006) in Venezuela in 2006 to that in 2008?
Your answer should be very brief. 0.93. What is the ratio of the Production index(2004-2006) in Djibouti in 2007 to that in 2008?
Give a very brief answer. 1.06. What is the ratio of the Production index(2004-2006) of Tajikistan in 2007 to that in 2008?
Provide a short and direct response. 0.97. What is the ratio of the Production index(2004-2006) in Venezuela in 2007 to that in 2008?
Make the answer very short. 0.96. What is the difference between the highest and the second highest Production index(2004-2006) of Brunei Darussalam?
Offer a very short reply. 5.21. What is the difference between the highest and the second highest Production index(2004-2006) of Djibouti?
Ensure brevity in your answer.  0.52. What is the difference between the highest and the second highest Production index(2004-2006) in Tajikistan?
Give a very brief answer. 3.68. What is the difference between the highest and the second highest Production index(2004-2006) in Venezuela?
Your answer should be very brief. 4.61. What is the difference between the highest and the lowest Production index(2004-2006) in Djibouti?
Offer a very short reply. 19.05. What is the difference between the highest and the lowest Production index(2004-2006) in Tajikistan?
Offer a terse response. 20.8. What is the difference between the highest and the lowest Production index(2004-2006) in Venezuela?
Provide a succinct answer. 19.98. 